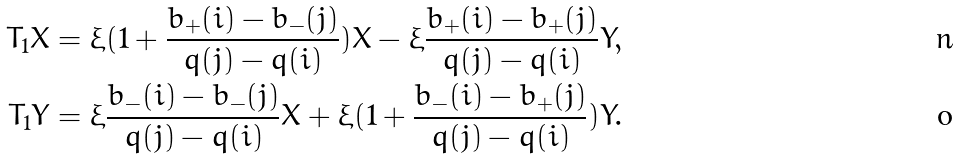<formula> <loc_0><loc_0><loc_500><loc_500>T _ { 1 } X & = \xi ( 1 + \frac { b _ { + } ( i ) - b _ { - } ( j ) } { q ( j ) - q ( i ) } ) X - \xi \frac { b _ { + } ( i ) - b _ { + } ( j ) } { q ( j ) - q ( i ) } Y , \\ T _ { 1 } Y & = \xi \frac { b _ { - } ( i ) - b _ { - } ( j ) } { q ( j ) - q ( i ) } X + \xi ( 1 + \frac { b _ { - } ( i ) - b _ { + } ( j ) } { q ( j ) - q ( i ) } ) Y .</formula> 